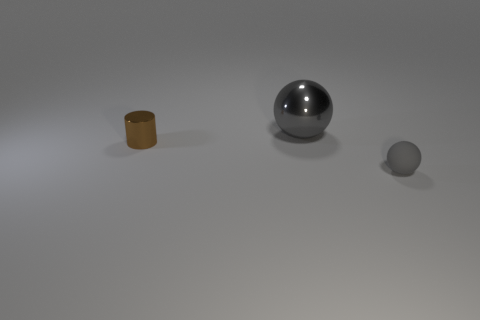Is there anything else that is made of the same material as the small gray object?
Offer a terse response. No. Is there anything else of the same color as the small shiny cylinder?
Your answer should be very brief. No. Do the brown cylinder and the gray shiny ball have the same size?
Offer a terse response. No. What number of other things are there of the same size as the gray matte ball?
Offer a terse response. 1. How big is the metal thing in front of the big gray shiny sphere?
Provide a short and direct response. Small. Is there a big gray sphere to the right of the thing that is to the right of the large gray thing?
Your response must be concise. No. Do the tiny object to the left of the large gray sphere and the large ball have the same material?
Your answer should be compact. Yes. How many objects are both to the right of the small shiny thing and behind the tiny rubber thing?
Your answer should be compact. 1. How many gray things are the same material as the small brown thing?
Ensure brevity in your answer.  1. There is a large ball that is made of the same material as the tiny brown cylinder; what color is it?
Offer a terse response. Gray. 